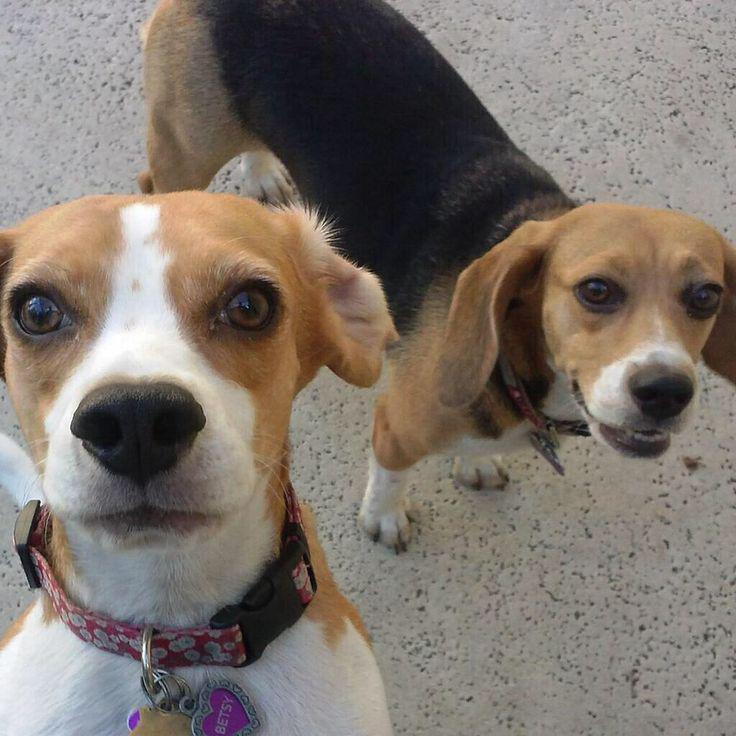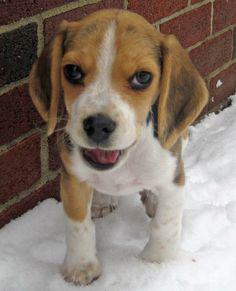The first image is the image on the left, the second image is the image on the right. Considering the images on both sides, is "A dog has its tongue visible while looking at the camera." valid? Answer yes or no. Yes. The first image is the image on the left, the second image is the image on the right. Analyze the images presented: Is the assertion "Right image shows a camera-facing beagle with its tongue at least partly showing." valid? Answer yes or no. Yes. 